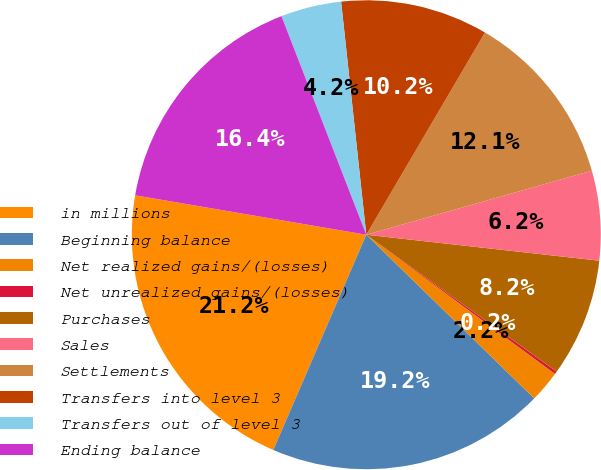Convert chart to OTSL. <chart><loc_0><loc_0><loc_500><loc_500><pie_chart><fcel>in millions<fcel>Beginning balance<fcel>Net realized gains/(losses)<fcel>Net unrealized gains/(losses)<fcel>Purchases<fcel>Sales<fcel>Settlements<fcel>Transfers into level 3<fcel>Transfers out of level 3<fcel>Ending balance<nl><fcel>21.2%<fcel>19.2%<fcel>2.18%<fcel>0.19%<fcel>8.16%<fcel>6.17%<fcel>12.15%<fcel>10.16%<fcel>4.18%<fcel>16.42%<nl></chart> 